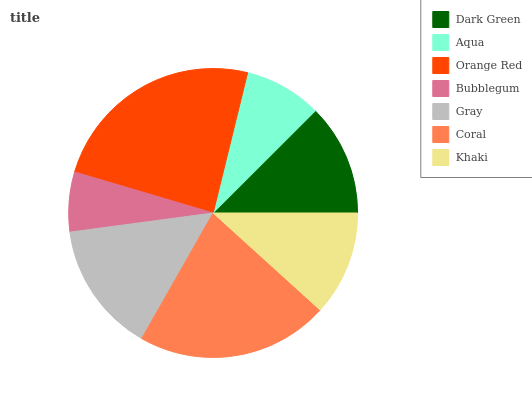Is Bubblegum the minimum?
Answer yes or no. Yes. Is Orange Red the maximum?
Answer yes or no. Yes. Is Aqua the minimum?
Answer yes or no. No. Is Aqua the maximum?
Answer yes or no. No. Is Dark Green greater than Aqua?
Answer yes or no. Yes. Is Aqua less than Dark Green?
Answer yes or no. Yes. Is Aqua greater than Dark Green?
Answer yes or no. No. Is Dark Green less than Aqua?
Answer yes or no. No. Is Dark Green the high median?
Answer yes or no. Yes. Is Dark Green the low median?
Answer yes or no. Yes. Is Aqua the high median?
Answer yes or no. No. Is Bubblegum the low median?
Answer yes or no. No. 